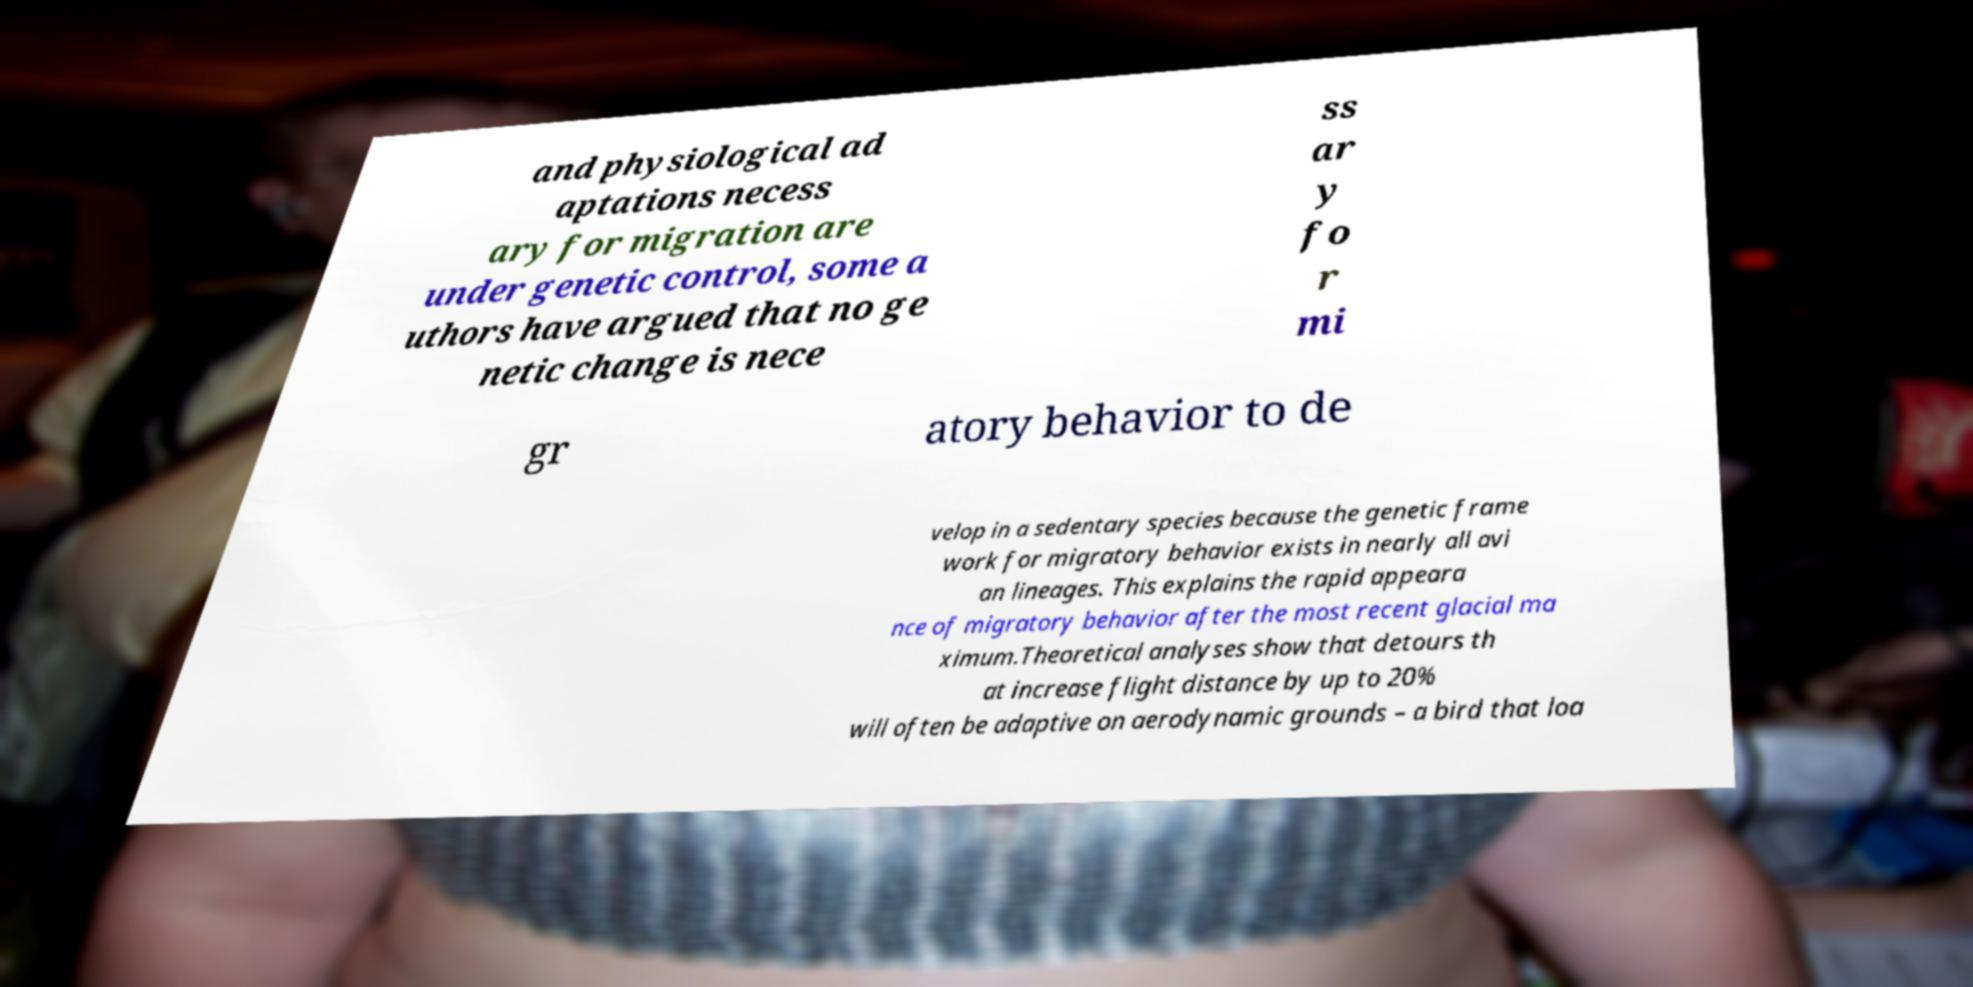Can you accurately transcribe the text from the provided image for me? and physiological ad aptations necess ary for migration are under genetic control, some a uthors have argued that no ge netic change is nece ss ar y fo r mi gr atory behavior to de velop in a sedentary species because the genetic frame work for migratory behavior exists in nearly all avi an lineages. This explains the rapid appeara nce of migratory behavior after the most recent glacial ma ximum.Theoretical analyses show that detours th at increase flight distance by up to 20% will often be adaptive on aerodynamic grounds – a bird that loa 